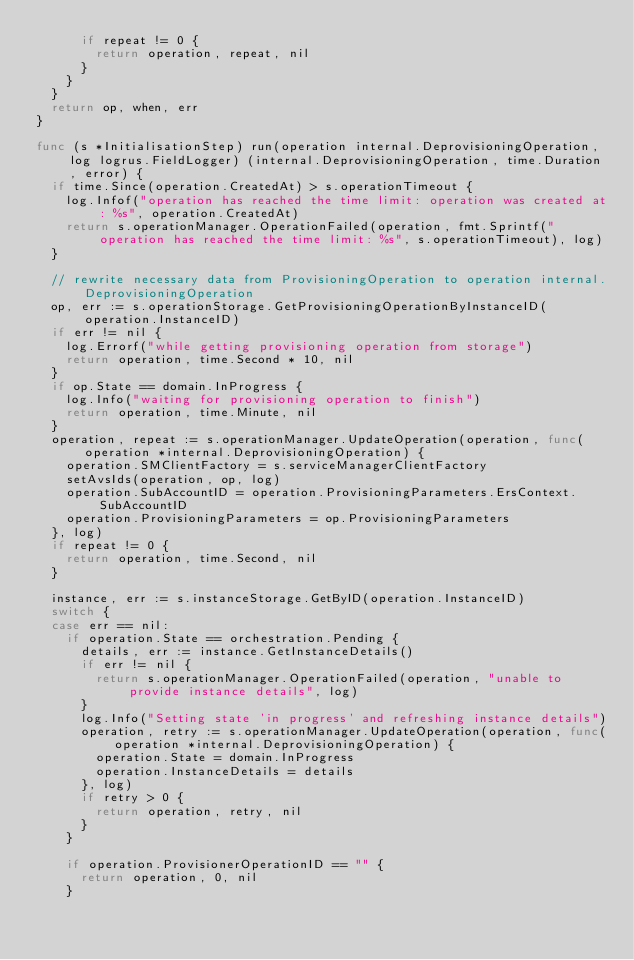Convert code to text. <code><loc_0><loc_0><loc_500><loc_500><_Go_>			if repeat != 0 {
				return operation, repeat, nil
			}
		}
	}
	return op, when, err
}

func (s *InitialisationStep) run(operation internal.DeprovisioningOperation, log logrus.FieldLogger) (internal.DeprovisioningOperation, time.Duration, error) {
	if time.Since(operation.CreatedAt) > s.operationTimeout {
		log.Infof("operation has reached the time limit: operation was created at: %s", operation.CreatedAt)
		return s.operationManager.OperationFailed(operation, fmt.Sprintf("operation has reached the time limit: %s", s.operationTimeout), log)
	}

	// rewrite necessary data from ProvisioningOperation to operation internal.DeprovisioningOperation
	op, err := s.operationStorage.GetProvisioningOperationByInstanceID(operation.InstanceID)
	if err != nil {
		log.Errorf("while getting provisioning operation from storage")
		return operation, time.Second * 10, nil
	}
	if op.State == domain.InProgress {
		log.Info("waiting for provisioning operation to finish")
		return operation, time.Minute, nil
	}
	operation, repeat := s.operationManager.UpdateOperation(operation, func(operation *internal.DeprovisioningOperation) {
		operation.SMClientFactory = s.serviceManagerClientFactory
		setAvsIds(operation, op, log)
		operation.SubAccountID = operation.ProvisioningParameters.ErsContext.SubAccountID
		operation.ProvisioningParameters = op.ProvisioningParameters
	}, log)
	if repeat != 0 {
		return operation, time.Second, nil
	}

	instance, err := s.instanceStorage.GetByID(operation.InstanceID)
	switch {
	case err == nil:
		if operation.State == orchestration.Pending {
			details, err := instance.GetInstanceDetails()
			if err != nil {
				return s.operationManager.OperationFailed(operation, "unable to provide instance details", log)
			}
			log.Info("Setting state 'in progress' and refreshing instance details")
			operation, retry := s.operationManager.UpdateOperation(operation, func(operation *internal.DeprovisioningOperation) {
				operation.State = domain.InProgress
				operation.InstanceDetails = details
			}, log)
			if retry > 0 {
				return operation, retry, nil
			}
		}

		if operation.ProvisionerOperationID == "" {
			return operation, 0, nil
		}</code> 